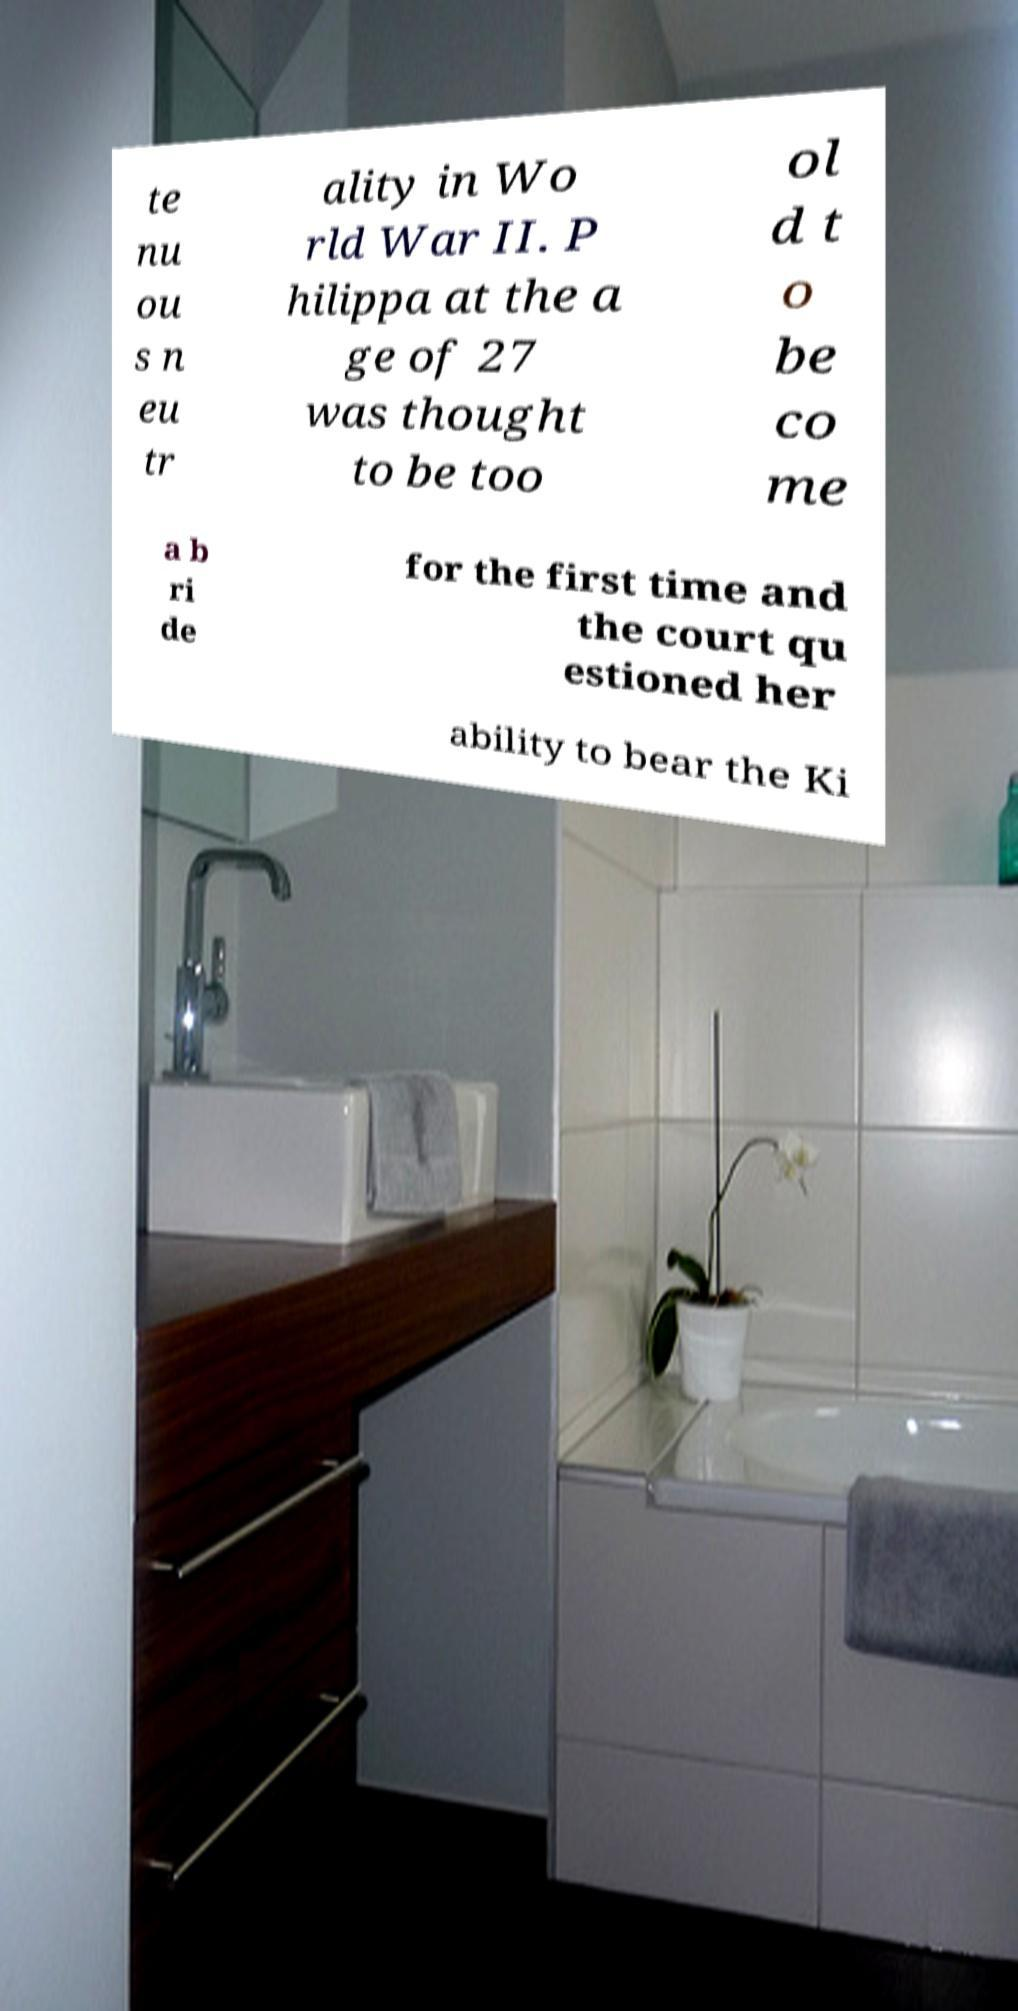Could you assist in decoding the text presented in this image and type it out clearly? te nu ou s n eu tr ality in Wo rld War II. P hilippa at the a ge of 27 was thought to be too ol d t o be co me a b ri de for the first time and the court qu estioned her ability to bear the Ki 